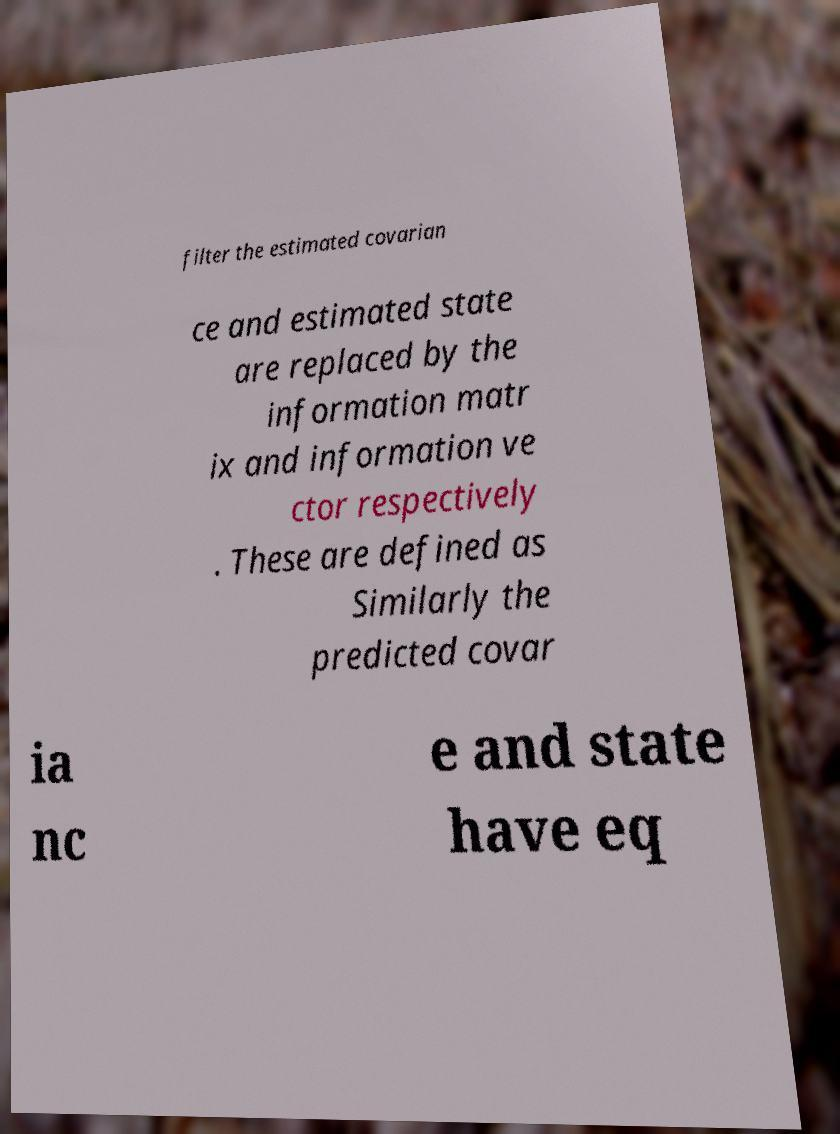Could you assist in decoding the text presented in this image and type it out clearly? filter the estimated covarian ce and estimated state are replaced by the information matr ix and information ve ctor respectively . These are defined as Similarly the predicted covar ia nc e and state have eq 